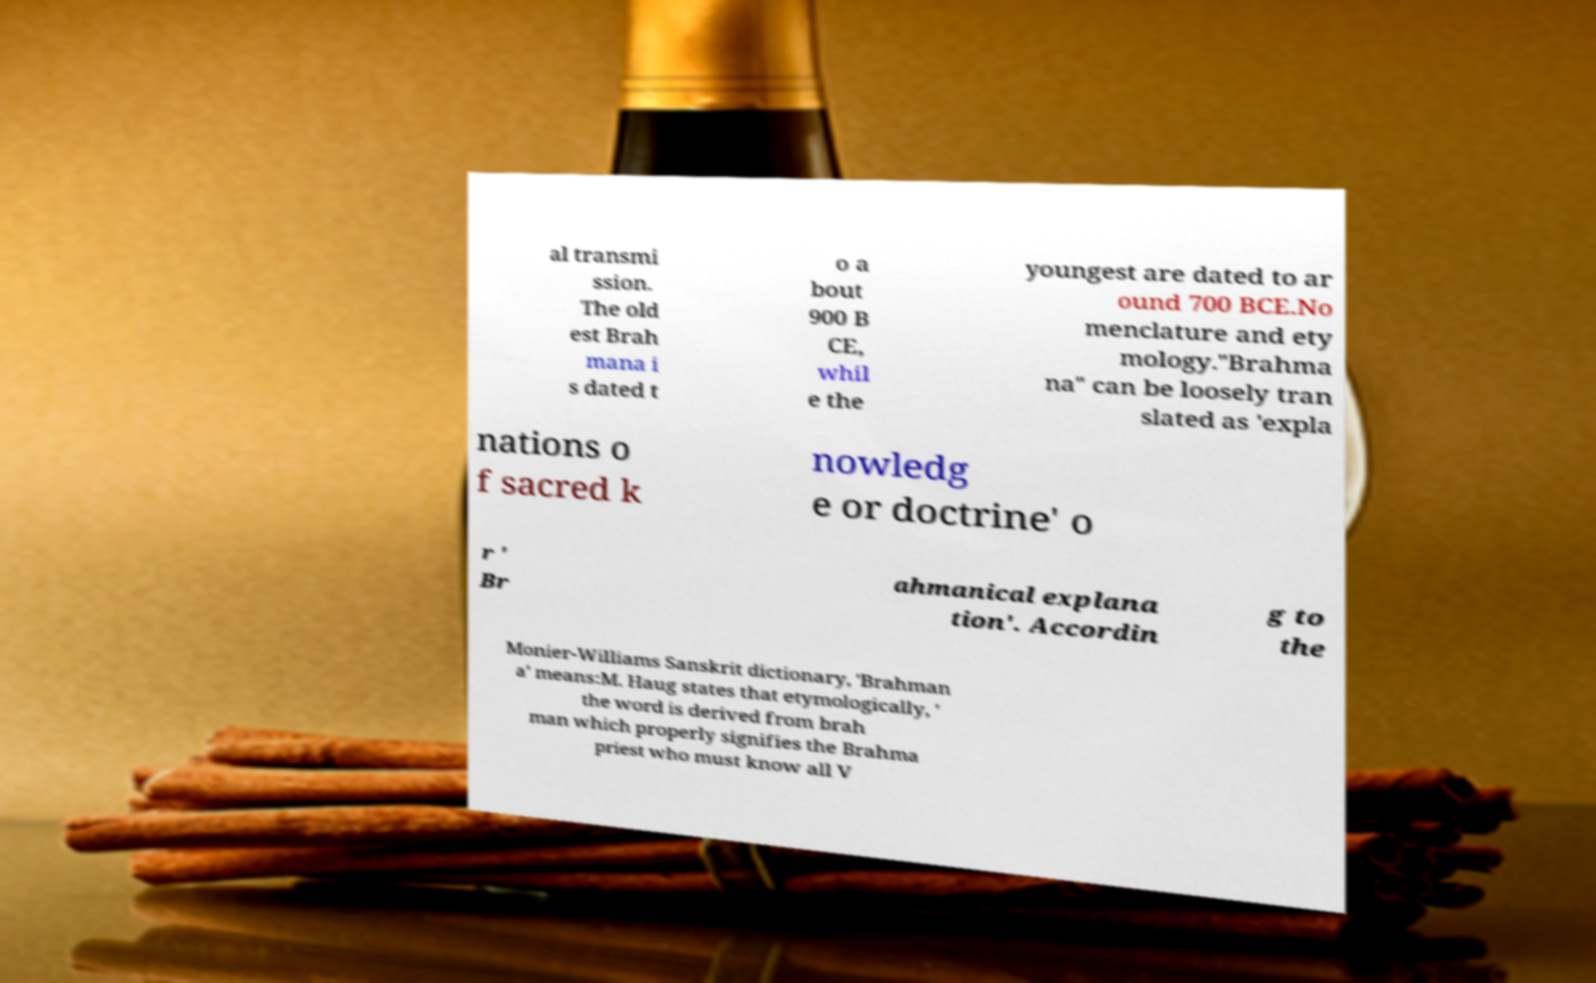Could you assist in decoding the text presented in this image and type it out clearly? al transmi ssion. The old est Brah mana i s dated t o a bout 900 B CE, whil e the youngest are dated to ar ound 700 BCE.No menclature and ety mology."Brahma na" can be loosely tran slated as 'expla nations o f sacred k nowledg e or doctrine' o r ' Br ahmanical explana tion'. Accordin g to the Monier-Williams Sanskrit dictionary, 'Brahman a' means:M. Haug states that etymologically, ' the word is derived from brah man which properly signifies the Brahma priest who must know all V 